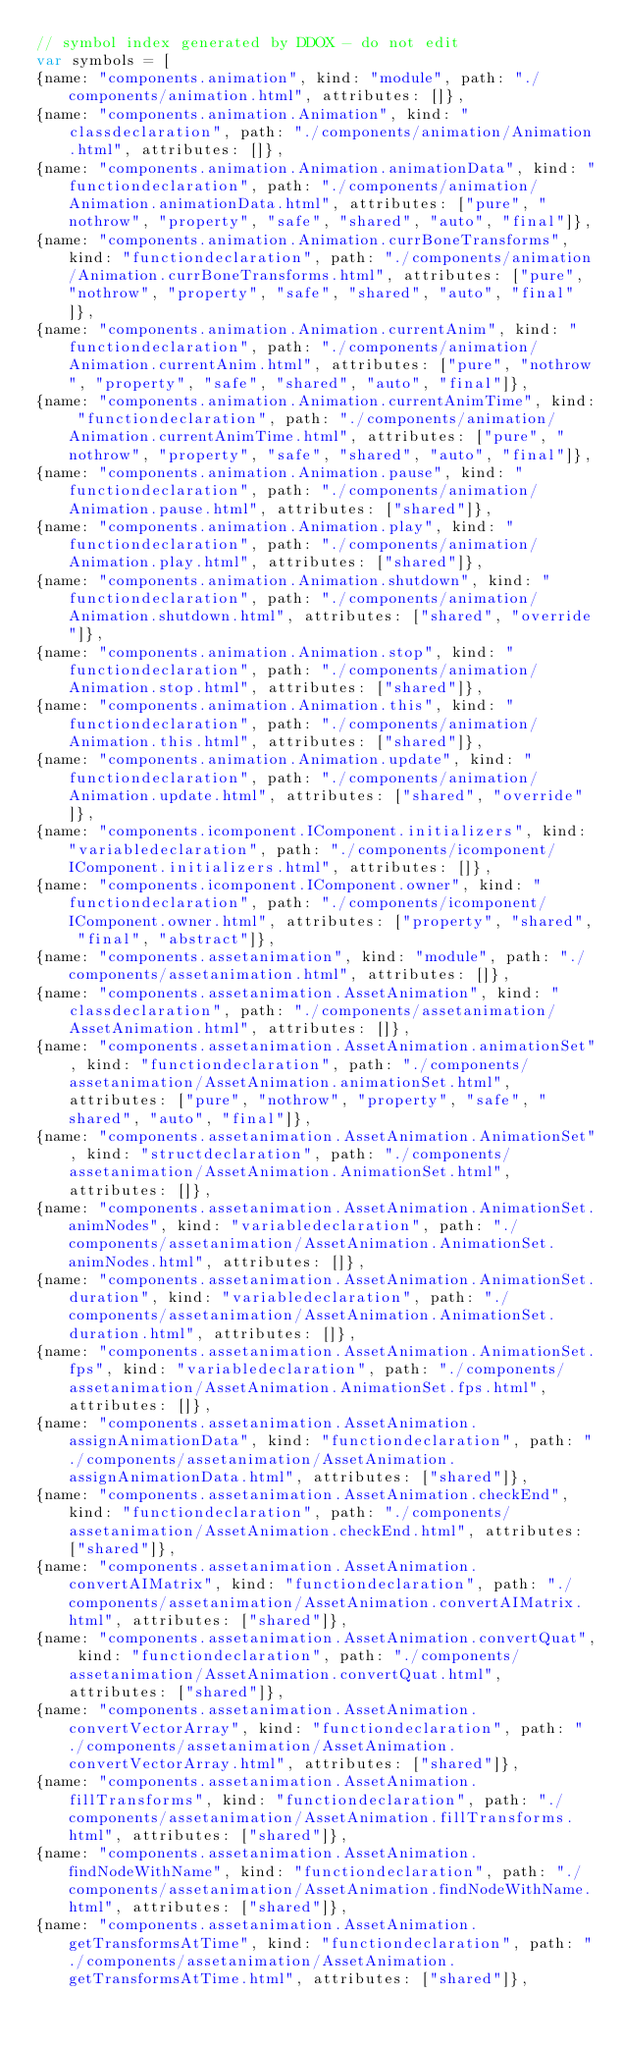<code> <loc_0><loc_0><loc_500><loc_500><_JavaScript_>// symbol index generated by DDOX - do not edit
var symbols = [
{name: "components.animation", kind: "module", path: "./components/animation.html", attributes: []},
{name: "components.animation.Animation", kind: "classdeclaration", path: "./components/animation/Animation.html", attributes: []},
{name: "components.animation.Animation.animationData", kind: "functiondeclaration", path: "./components/animation/Animation.animationData.html", attributes: ["pure", "nothrow", "property", "safe", "shared", "auto", "final"]},
{name: "components.animation.Animation.currBoneTransforms", kind: "functiondeclaration", path: "./components/animation/Animation.currBoneTransforms.html", attributes: ["pure", "nothrow", "property", "safe", "shared", "auto", "final"]},
{name: "components.animation.Animation.currentAnim", kind: "functiondeclaration", path: "./components/animation/Animation.currentAnim.html", attributes: ["pure", "nothrow", "property", "safe", "shared", "auto", "final"]},
{name: "components.animation.Animation.currentAnimTime", kind: "functiondeclaration", path: "./components/animation/Animation.currentAnimTime.html", attributes: ["pure", "nothrow", "property", "safe", "shared", "auto", "final"]},
{name: "components.animation.Animation.pause", kind: "functiondeclaration", path: "./components/animation/Animation.pause.html", attributes: ["shared"]},
{name: "components.animation.Animation.play", kind: "functiondeclaration", path: "./components/animation/Animation.play.html", attributes: ["shared"]},
{name: "components.animation.Animation.shutdown", kind: "functiondeclaration", path: "./components/animation/Animation.shutdown.html", attributes: ["shared", "override"]},
{name: "components.animation.Animation.stop", kind: "functiondeclaration", path: "./components/animation/Animation.stop.html", attributes: ["shared"]},
{name: "components.animation.Animation.this", kind: "functiondeclaration", path: "./components/animation/Animation.this.html", attributes: ["shared"]},
{name: "components.animation.Animation.update", kind: "functiondeclaration", path: "./components/animation/Animation.update.html", attributes: ["shared", "override"]},
{name: "components.icomponent.IComponent.initializers", kind: "variabledeclaration", path: "./components/icomponent/IComponent.initializers.html", attributes: []},
{name: "components.icomponent.IComponent.owner", kind: "functiondeclaration", path: "./components/icomponent/IComponent.owner.html", attributes: ["property", "shared", "final", "abstract"]},
{name: "components.assetanimation", kind: "module", path: "./components/assetanimation.html", attributes: []},
{name: "components.assetanimation.AssetAnimation", kind: "classdeclaration", path: "./components/assetanimation/AssetAnimation.html", attributes: []},
{name: "components.assetanimation.AssetAnimation.animationSet", kind: "functiondeclaration", path: "./components/assetanimation/AssetAnimation.animationSet.html", attributes: ["pure", "nothrow", "property", "safe", "shared", "auto", "final"]},
{name: "components.assetanimation.AssetAnimation.AnimationSet", kind: "structdeclaration", path: "./components/assetanimation/AssetAnimation.AnimationSet.html", attributes: []},
{name: "components.assetanimation.AssetAnimation.AnimationSet.animNodes", kind: "variabledeclaration", path: "./components/assetanimation/AssetAnimation.AnimationSet.animNodes.html", attributes: []},
{name: "components.assetanimation.AssetAnimation.AnimationSet.duration", kind: "variabledeclaration", path: "./components/assetanimation/AssetAnimation.AnimationSet.duration.html", attributes: []},
{name: "components.assetanimation.AssetAnimation.AnimationSet.fps", kind: "variabledeclaration", path: "./components/assetanimation/AssetAnimation.AnimationSet.fps.html", attributes: []},
{name: "components.assetanimation.AssetAnimation.assignAnimationData", kind: "functiondeclaration", path: "./components/assetanimation/AssetAnimation.assignAnimationData.html", attributes: ["shared"]},
{name: "components.assetanimation.AssetAnimation.checkEnd", kind: "functiondeclaration", path: "./components/assetanimation/AssetAnimation.checkEnd.html", attributes: ["shared"]},
{name: "components.assetanimation.AssetAnimation.convertAIMatrix", kind: "functiondeclaration", path: "./components/assetanimation/AssetAnimation.convertAIMatrix.html", attributes: ["shared"]},
{name: "components.assetanimation.AssetAnimation.convertQuat", kind: "functiondeclaration", path: "./components/assetanimation/AssetAnimation.convertQuat.html", attributes: ["shared"]},
{name: "components.assetanimation.AssetAnimation.convertVectorArray", kind: "functiondeclaration", path: "./components/assetanimation/AssetAnimation.convertVectorArray.html", attributes: ["shared"]},
{name: "components.assetanimation.AssetAnimation.fillTransforms", kind: "functiondeclaration", path: "./components/assetanimation/AssetAnimation.fillTransforms.html", attributes: ["shared"]},
{name: "components.assetanimation.AssetAnimation.findNodeWithName", kind: "functiondeclaration", path: "./components/assetanimation/AssetAnimation.findNodeWithName.html", attributes: ["shared"]},
{name: "components.assetanimation.AssetAnimation.getTransformsAtTime", kind: "functiondeclaration", path: "./components/assetanimation/AssetAnimation.getTransformsAtTime.html", attributes: ["shared"]},</code> 